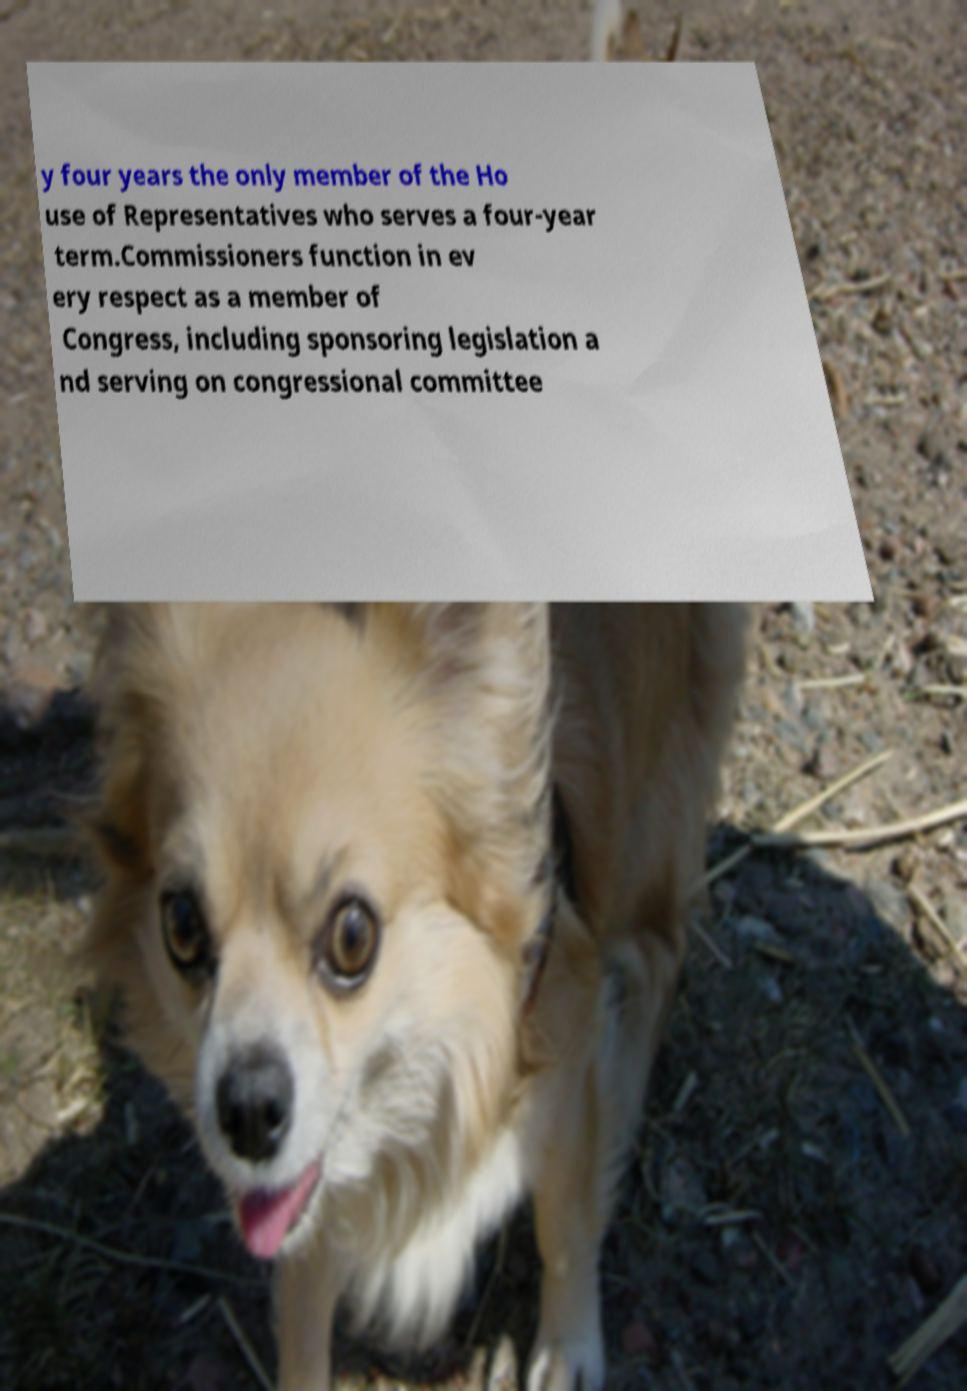Can you accurately transcribe the text from the provided image for me? y four years the only member of the Ho use of Representatives who serves a four-year term.Commissioners function in ev ery respect as a member of Congress, including sponsoring legislation a nd serving on congressional committee 